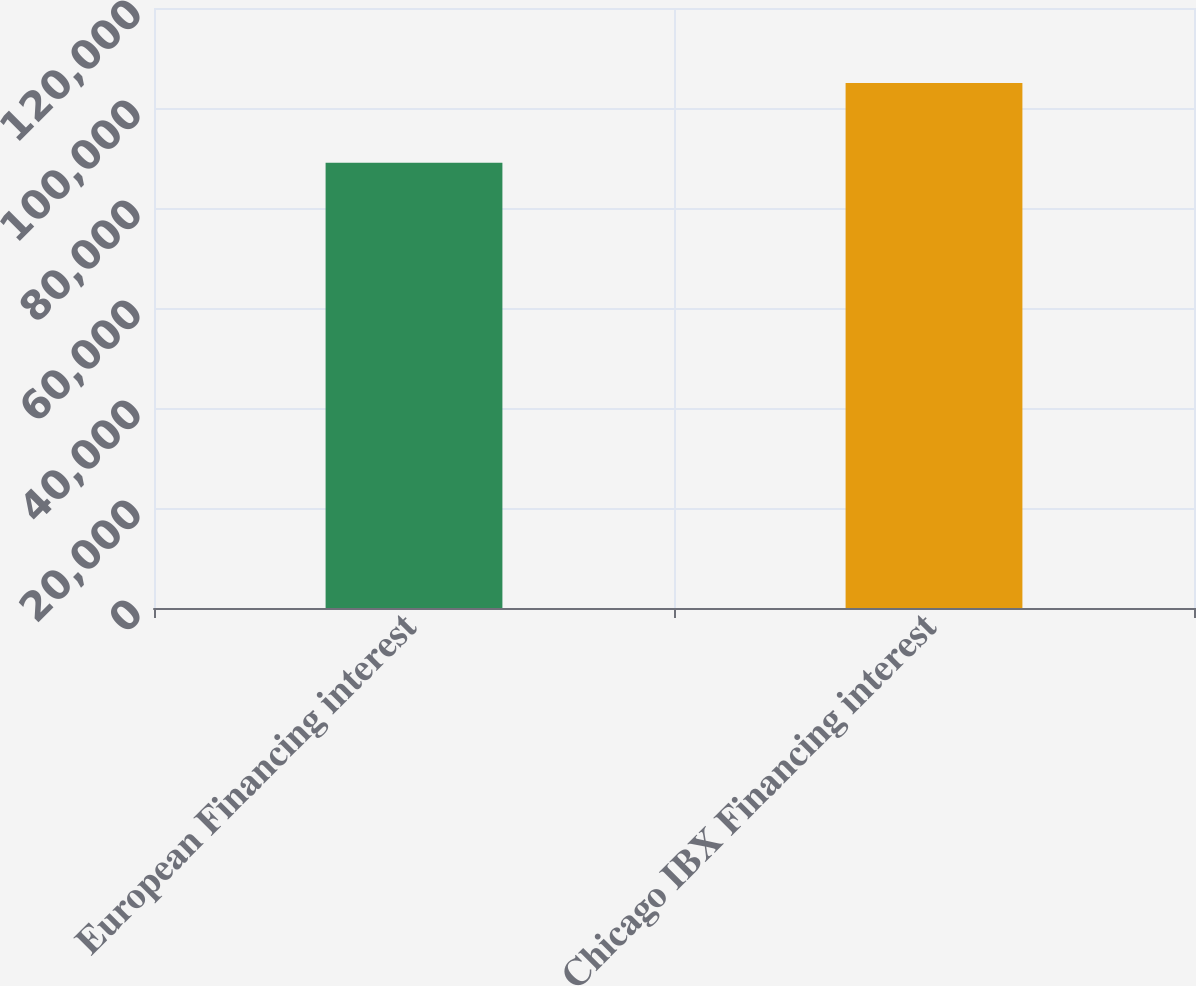Convert chart. <chart><loc_0><loc_0><loc_500><loc_500><bar_chart><fcel>European Financing interest<fcel>Chicago IBX Financing interest<nl><fcel>89065<fcel>105000<nl></chart> 